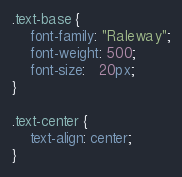Convert code to text. <code><loc_0><loc_0><loc_500><loc_500><_CSS_>.text-base {
	font-family: "Raleway";
	font-weight: 500;
	font-size:   20px;
}

.text-center {
	text-align: center;
}</code> 